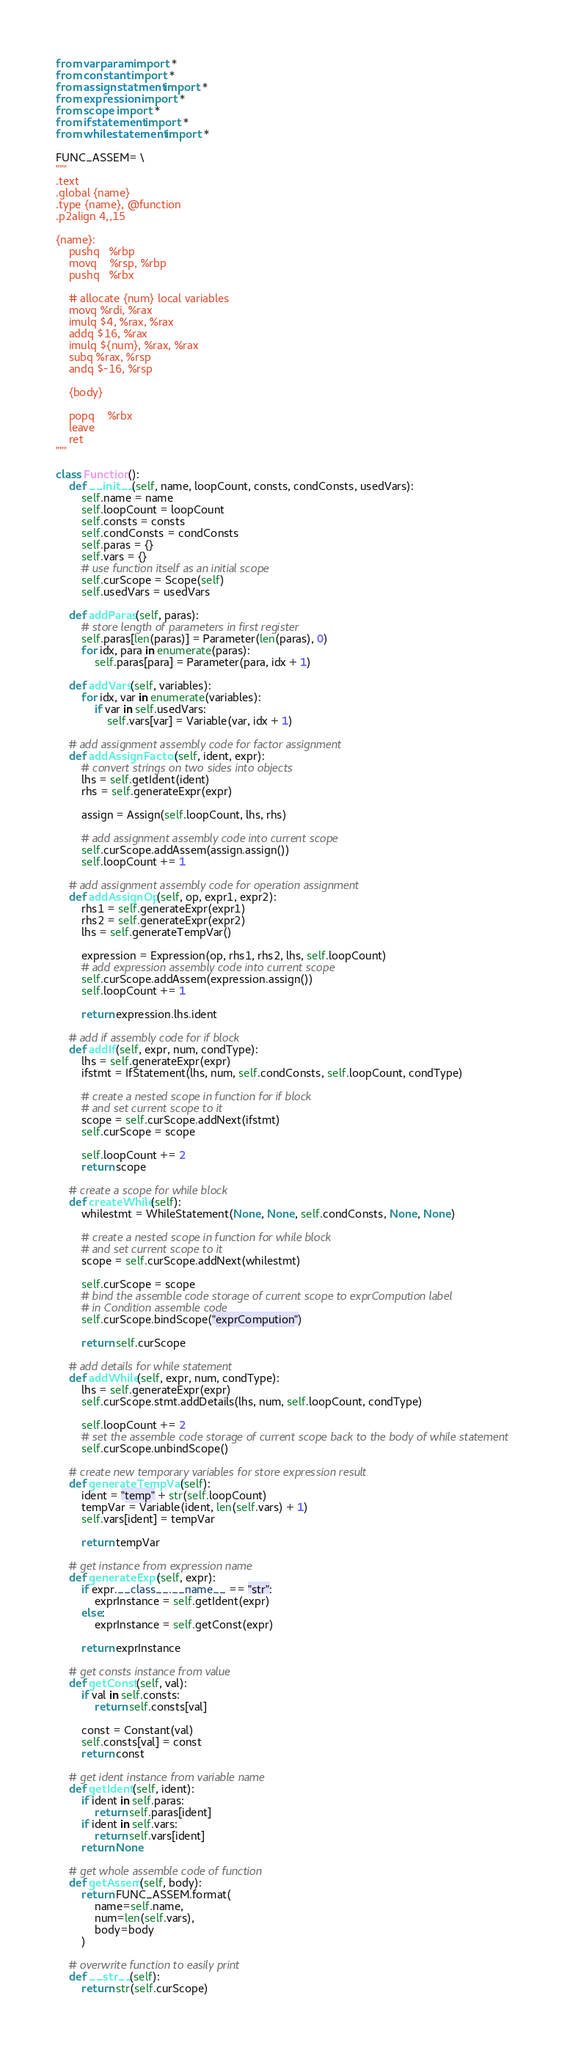<code> <loc_0><loc_0><loc_500><loc_500><_Python_>from varparam import *
from constant import *
from assignstatment import *
from expression import *
from scope import *
from ifstatement import *
from whilestatement import *

FUNC_ASSEM= \
"""
.text
.global {name}
.type {name}, @function
.p2align 4,,15

{name}:
    pushq   %rbp
    movq    %rsp, %rbp
    pushq   %rbx

    # allocate {num} local variables
    movq %rdi, %rax
    imulq $4, %rax, %rax
    addq $16, %rax
    imulq ${num}, %rax, %rax
    subq %rax, %rsp
    andq $-16, %rsp

    {body}

    popq    %rbx
    leave
    ret
"""

class Function():
    def __init__(self, name, loopCount, consts, condConsts, usedVars):
        self.name = name
        self.loopCount = loopCount
        self.consts = consts
        self.condConsts = condConsts
        self.paras = {}
        self.vars = {}
        # use function itself as an initial scope
        self.curScope = Scope(self)
        self.usedVars = usedVars

    def addParas(self, paras):
        # store length of parameters in first register
        self.paras[len(paras)] = Parameter(len(paras), 0) 
        for idx, para in enumerate(paras):
            self.paras[para] = Parameter(para, idx + 1)

    def addVars(self, variables):
        for idx, var in enumerate(variables):
            if var in self.usedVars:
                self.vars[var] = Variable(var, idx + 1)

    # add assignment assembly code for factor assignment
    def addAssignFactor(self, ident, expr):
        # convert strings on two sides into objects
        lhs = self.getIdent(ident)
        rhs = self.generateExpr(expr)

        assign = Assign(self.loopCount, lhs, rhs)
        
        # add assignment assembly code into current scope
        self.curScope.addAssem(assign.assign())
        self.loopCount += 1

    # add assignment assembly code for operation assignment
    def addAssignOp(self, op, expr1, expr2):
        rhs1 = self.generateExpr(expr1)
        rhs2 = self.generateExpr(expr2) 
        lhs = self.generateTempVar()
        
        expression = Expression(op, rhs1, rhs2, lhs, self.loopCount)
        # add expression assembly code into current scope
        self.curScope.addAssem(expression.assign())
        self.loopCount += 1

        return expression.lhs.ident

    # add if assembly code for if block
    def addIf(self, expr, num, condType):
        lhs = self.generateExpr(expr)
        ifstmt = IfStatement(lhs, num, self.condConsts, self.loopCount, condType)
        
        # create a nested scope in function for if block 
        # and set current scope to it
        scope = self.curScope.addNext(ifstmt)
        self.curScope = scope

        self.loopCount += 2
        return scope

    # create a scope for while block
    def createWhile(self):
        whilestmt = WhileStatement(None, None, self.condConsts, None, None)
        
        # create a nested scope in function for while block 
        # and set current scope to it
        scope = self.curScope.addNext(whilestmt)

        self.curScope = scope
        # bind the assemble code storage of current scope to exprCompution label
        # in Condition assemble code
        self.curScope.bindScope("exprCompution")

        return self.curScope

    # add details for while statement 
    def addWhile(self, expr, num, condType):
        lhs = self.generateExpr(expr)
        self.curScope.stmt.addDetails(lhs, num, self.loopCount, condType)

        self.loopCount += 2
        # set the assemble code storage of current scope back to the body of while statement
        self.curScope.unbindScope()
    
    # create new temporary variables for store expression result
    def generateTempVar(self):
        ident = "temp" + str(self.loopCount)
        tempVar = Variable(ident, len(self.vars) + 1)
        self.vars[ident] = tempVar
        
        return tempVar

    # get instance from expression name
    def generateExpr(self, expr):
        if expr.__class__.__name__ == "str":
            exprInstance = self.getIdent(expr)
        else:
            exprInstance = self.getConst(expr) 

        return exprInstance

    # get consts instance from value
    def getConst(self, val):
        if val in self.consts:
            return self.consts[val]

        const = Constant(val)
        self.consts[val] = const
        return const
            
    # get ident instance from variable name
    def getIdent(self, ident):
        if ident in self.paras:
            return self.paras[ident]
        if ident in self.vars:
            return self.vars[ident]
        return None

    # get whole assemble code of function
    def getAssem(self, body):
        return FUNC_ASSEM.format(
            name=self.name,
            num=len(self.vars), 
            body=body
        )

    # overwrite function to easily print
    def __str__(self):
        return str(self.curScope)
</code> 